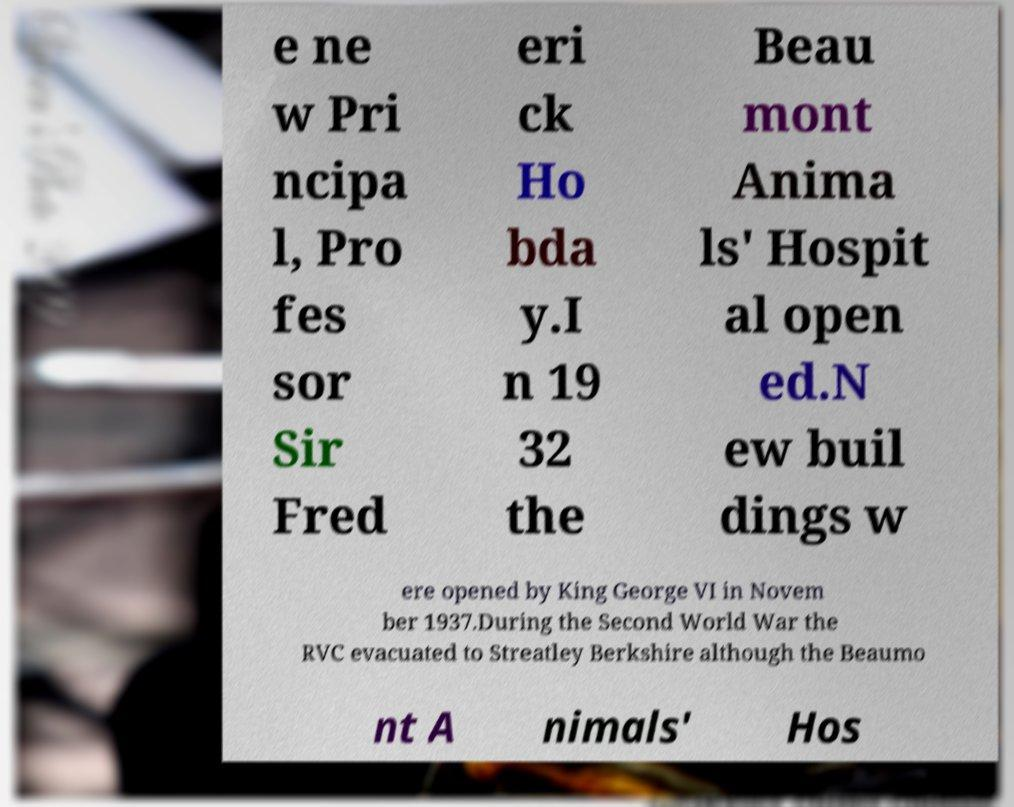Can you read and provide the text displayed in the image?This photo seems to have some interesting text. Can you extract and type it out for me? e ne w Pri ncipa l, Pro fes sor Sir Fred eri ck Ho bda y.I n 19 32 the Beau mont Anima ls' Hospit al open ed.N ew buil dings w ere opened by King George VI in Novem ber 1937.During the Second World War the RVC evacuated to Streatley Berkshire although the Beaumo nt A nimals' Hos 